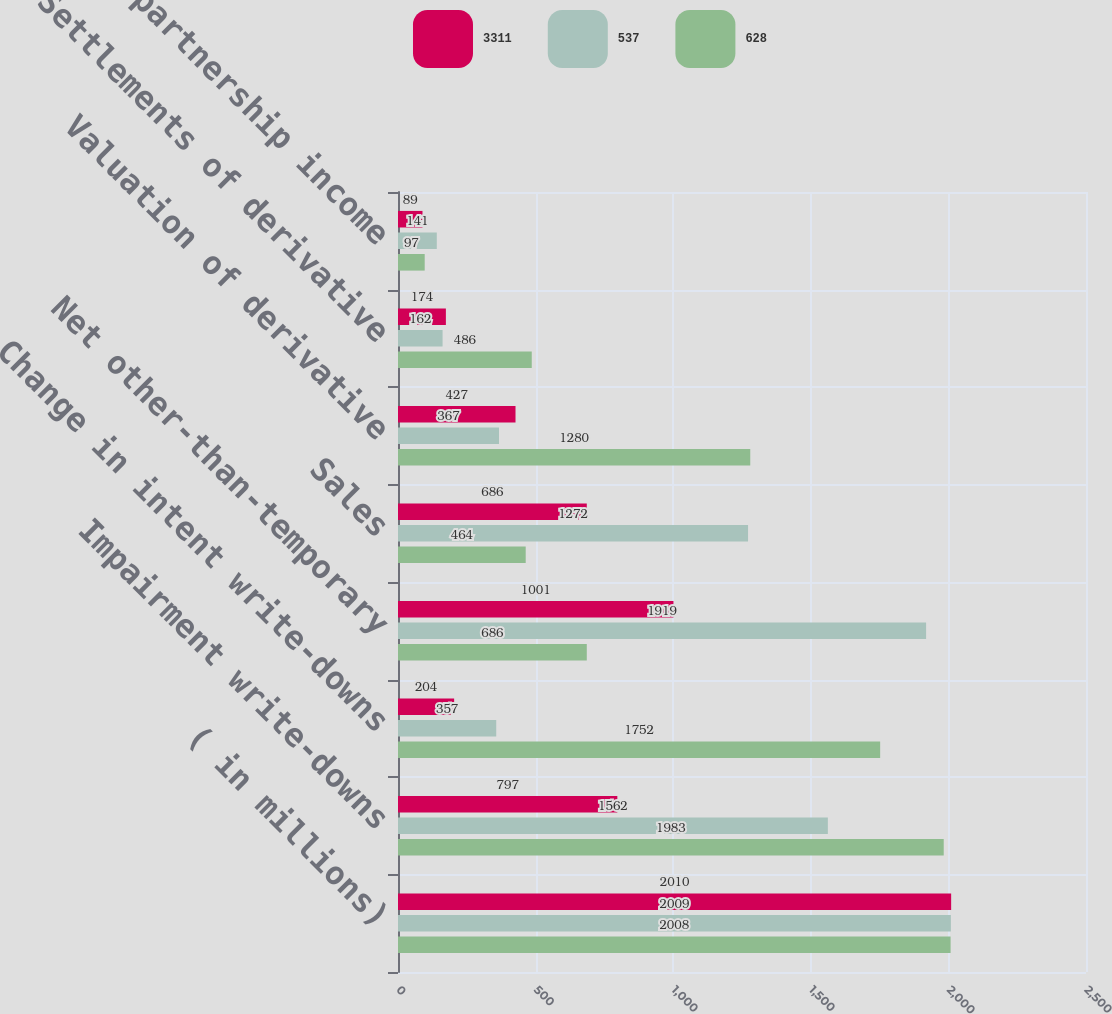Convert chart. <chart><loc_0><loc_0><loc_500><loc_500><stacked_bar_chart><ecel><fcel>( in millions)<fcel>Impairment write-downs<fcel>Change in intent write-downs<fcel>Net other-than-temporary<fcel>Sales<fcel>Valuation of derivative<fcel>Settlements of derivative<fcel>EMA limited partnership income<nl><fcel>3311<fcel>2010<fcel>797<fcel>204<fcel>1001<fcel>686<fcel>427<fcel>174<fcel>89<nl><fcel>537<fcel>2009<fcel>1562<fcel>357<fcel>1919<fcel>1272<fcel>367<fcel>162<fcel>141<nl><fcel>628<fcel>2008<fcel>1983<fcel>1752<fcel>686<fcel>464<fcel>1280<fcel>486<fcel>97<nl></chart> 